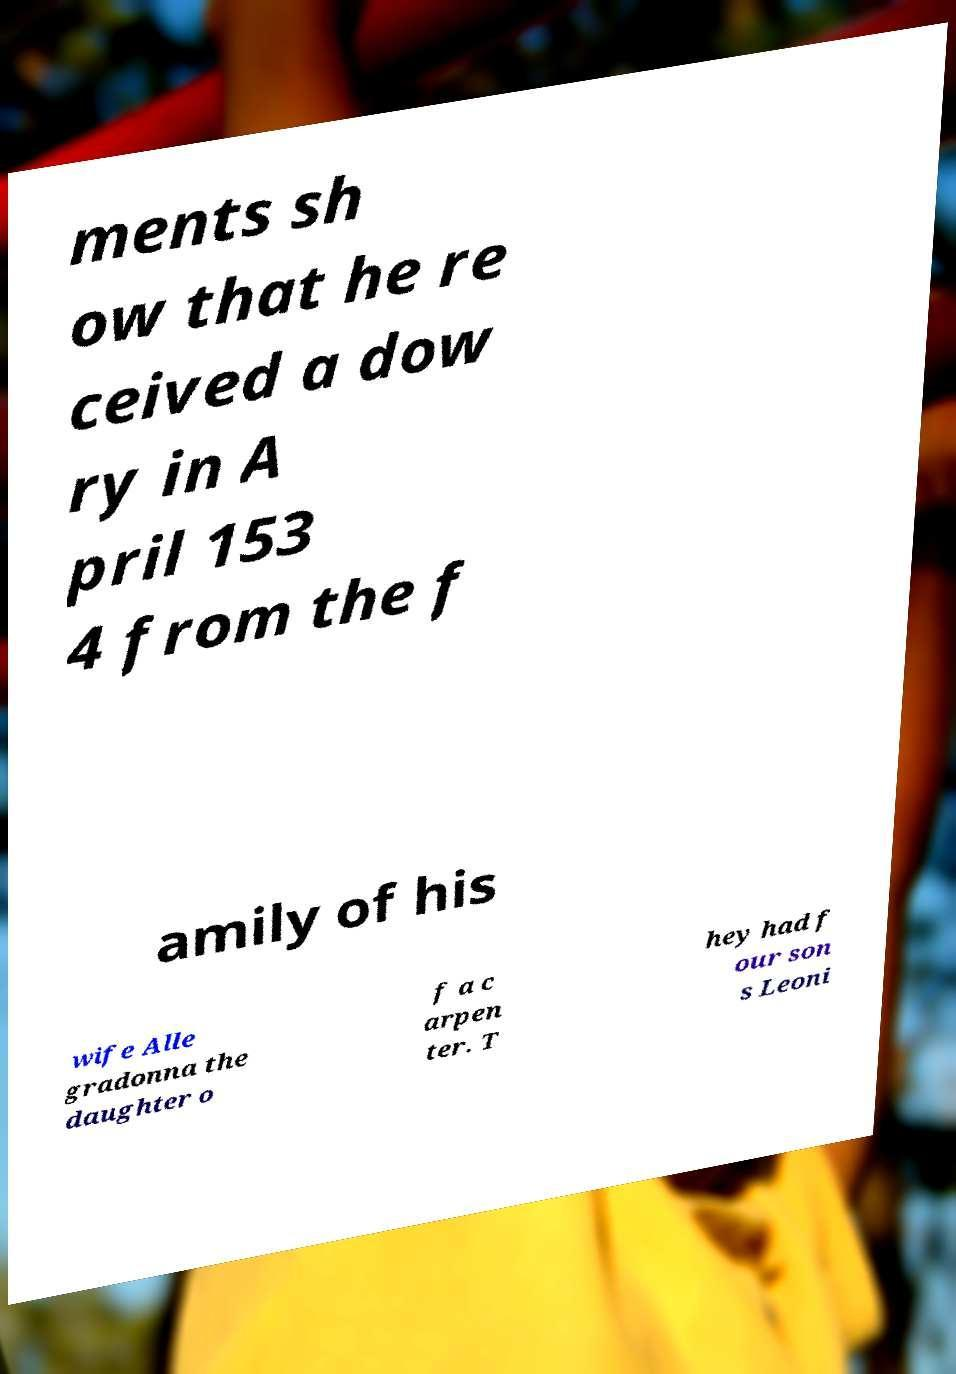For documentation purposes, I need the text within this image transcribed. Could you provide that? ments sh ow that he re ceived a dow ry in A pril 153 4 from the f amily of his wife Alle gradonna the daughter o f a c arpen ter. T hey had f our son s Leoni 